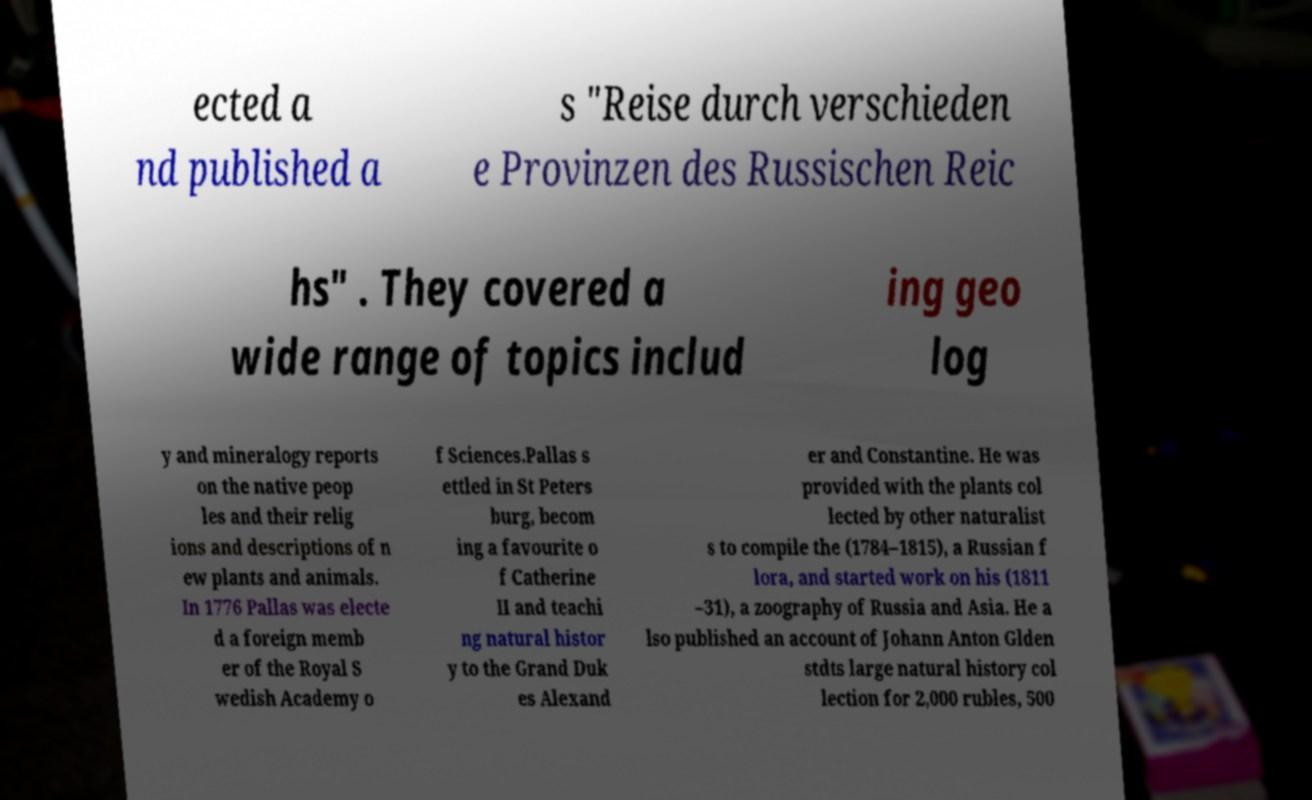What messages or text are displayed in this image? I need them in a readable, typed format. ected a nd published a s "Reise durch verschieden e Provinzen des Russischen Reic hs" . They covered a wide range of topics includ ing geo log y and mineralogy reports on the native peop les and their relig ions and descriptions of n ew plants and animals. In 1776 Pallas was electe d a foreign memb er of the Royal S wedish Academy o f Sciences.Pallas s ettled in St Peters burg, becom ing a favourite o f Catherine II and teachi ng natural histor y to the Grand Duk es Alexand er and Constantine. He was provided with the plants col lected by other naturalist s to compile the (1784–1815), a Russian f lora, and started work on his (1811 –31), a zoography of Russia and Asia. He a lso published an account of Johann Anton Glden stdts large natural history col lection for 2,000 rubles, 500 